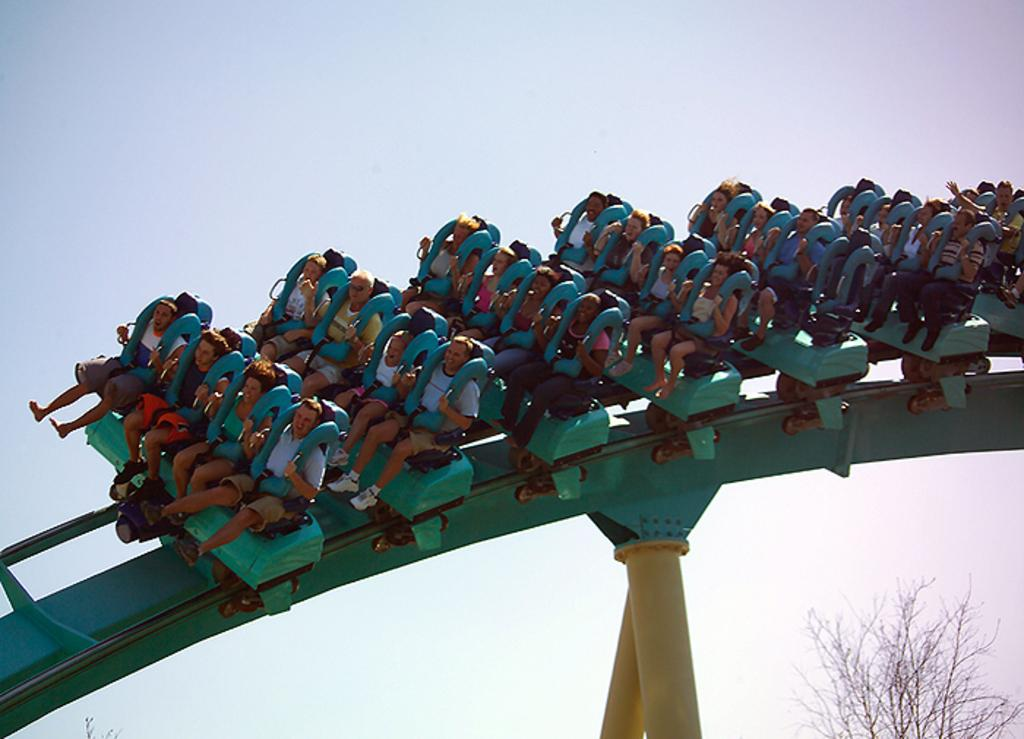What are the persons in the image doing? The persons in the image are sitting on a roller coaster. Can you describe the roller coaster's surroundings? There is a dry tree visible in the image. How does the cow in the image express hope? There is no cow present in the image, so it cannot express hope or any other emotion. 